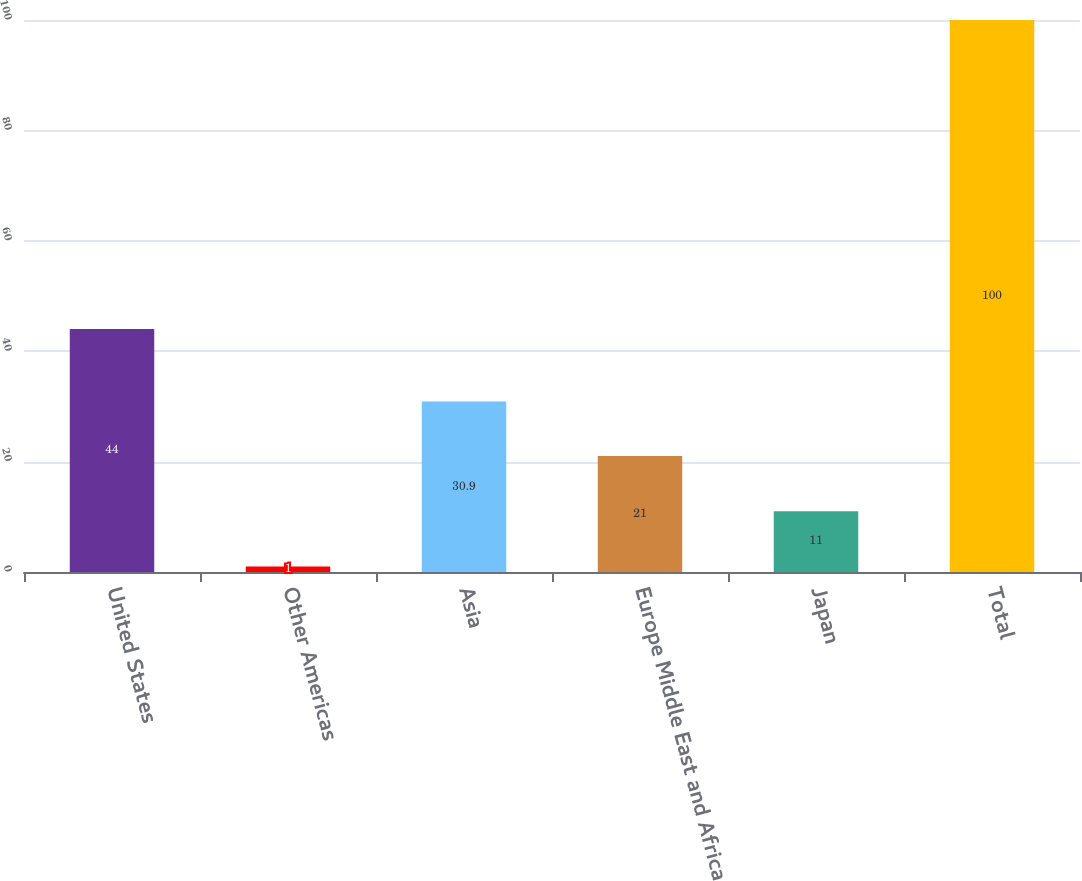<chart> <loc_0><loc_0><loc_500><loc_500><bar_chart><fcel>United States<fcel>Other Americas<fcel>Asia<fcel>Europe Middle East and Africa<fcel>Japan<fcel>Total<nl><fcel>44<fcel>1<fcel>30.9<fcel>21<fcel>11<fcel>100<nl></chart> 